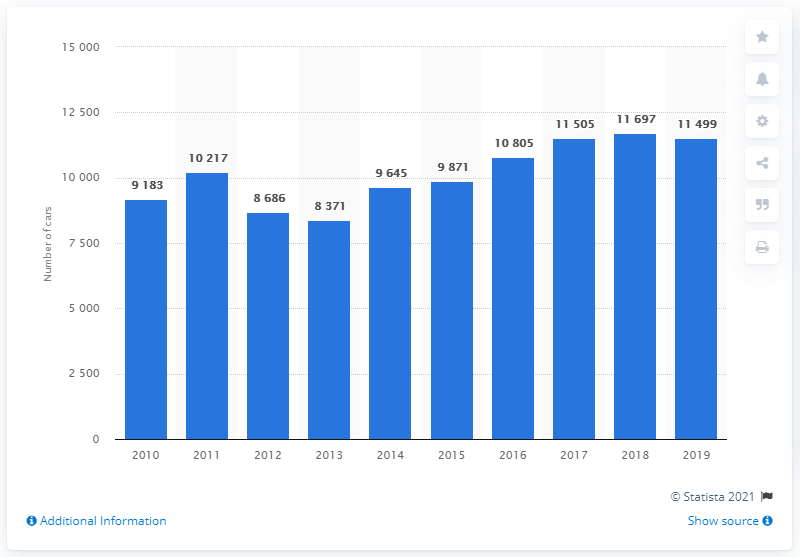Give some essential details in this illustration. In 2018, a total of 11,697 Skoda cars were sold in Finland. During the period of 2010 to 2019, a total of 11,499 Skoda cars were sold in Finland. 